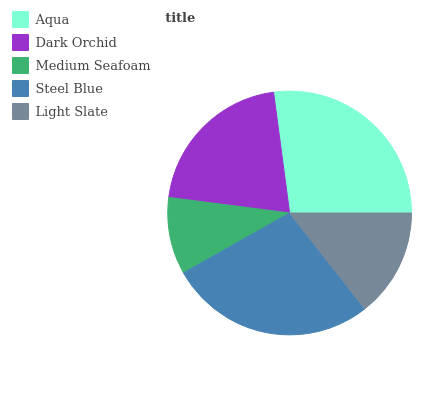Is Medium Seafoam the minimum?
Answer yes or no. Yes. Is Steel Blue the maximum?
Answer yes or no. Yes. Is Dark Orchid the minimum?
Answer yes or no. No. Is Dark Orchid the maximum?
Answer yes or no. No. Is Aqua greater than Dark Orchid?
Answer yes or no. Yes. Is Dark Orchid less than Aqua?
Answer yes or no. Yes. Is Dark Orchid greater than Aqua?
Answer yes or no. No. Is Aqua less than Dark Orchid?
Answer yes or no. No. Is Dark Orchid the high median?
Answer yes or no. Yes. Is Dark Orchid the low median?
Answer yes or no. Yes. Is Medium Seafoam the high median?
Answer yes or no. No. Is Medium Seafoam the low median?
Answer yes or no. No. 